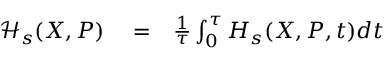Convert formula to latex. <formula><loc_0><loc_0><loc_500><loc_500>\begin{array} { r l r } { \mathcal { H } _ { s } ( X , P ) } & = } & { \frac { 1 } { \tau } \int _ { 0 } ^ { \tau } H _ { s } ( X , P , t ) d t } \end{array}</formula> 